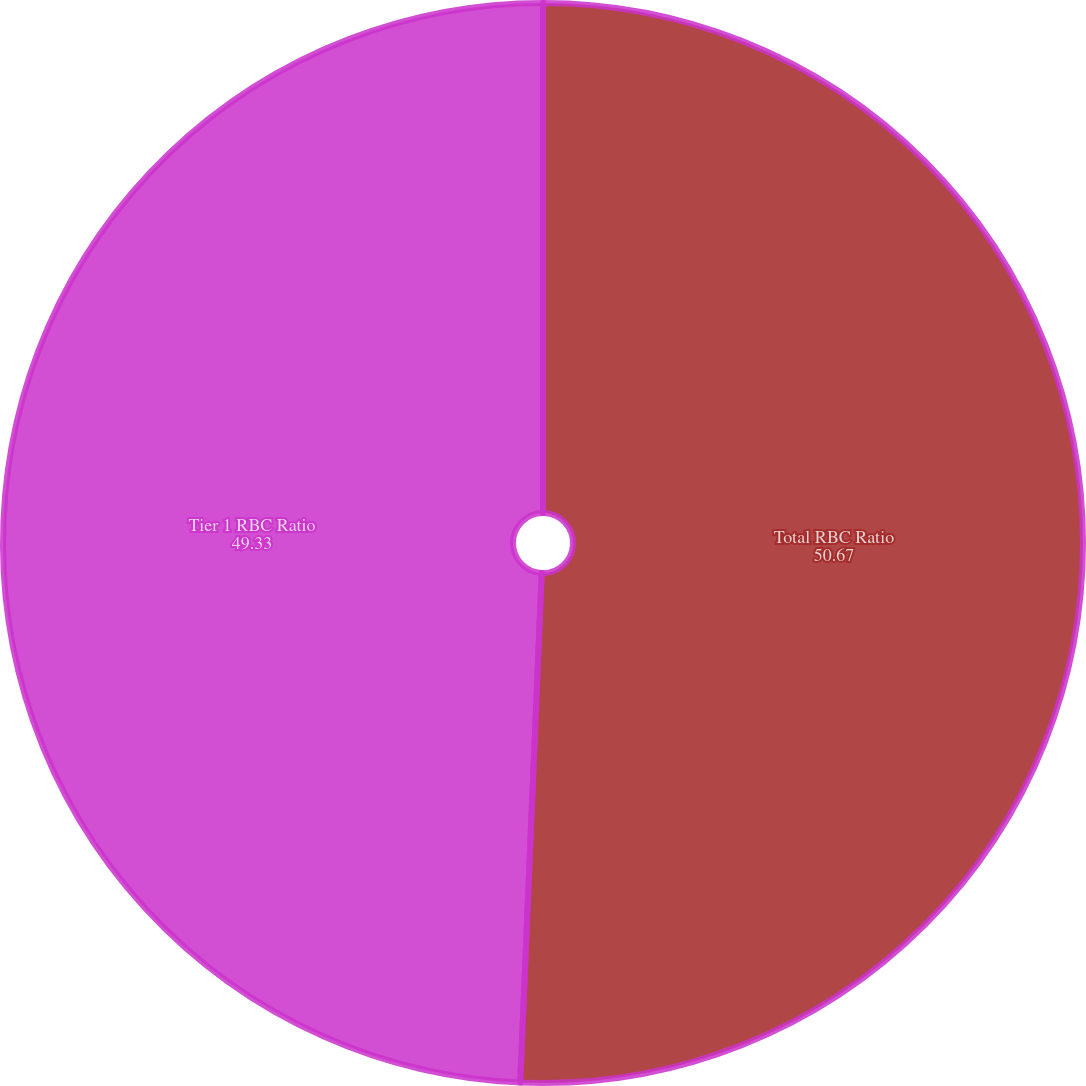<chart> <loc_0><loc_0><loc_500><loc_500><pie_chart><fcel>Total RBC Ratio<fcel>Tier 1 RBC Ratio<nl><fcel>50.67%<fcel>49.33%<nl></chart> 